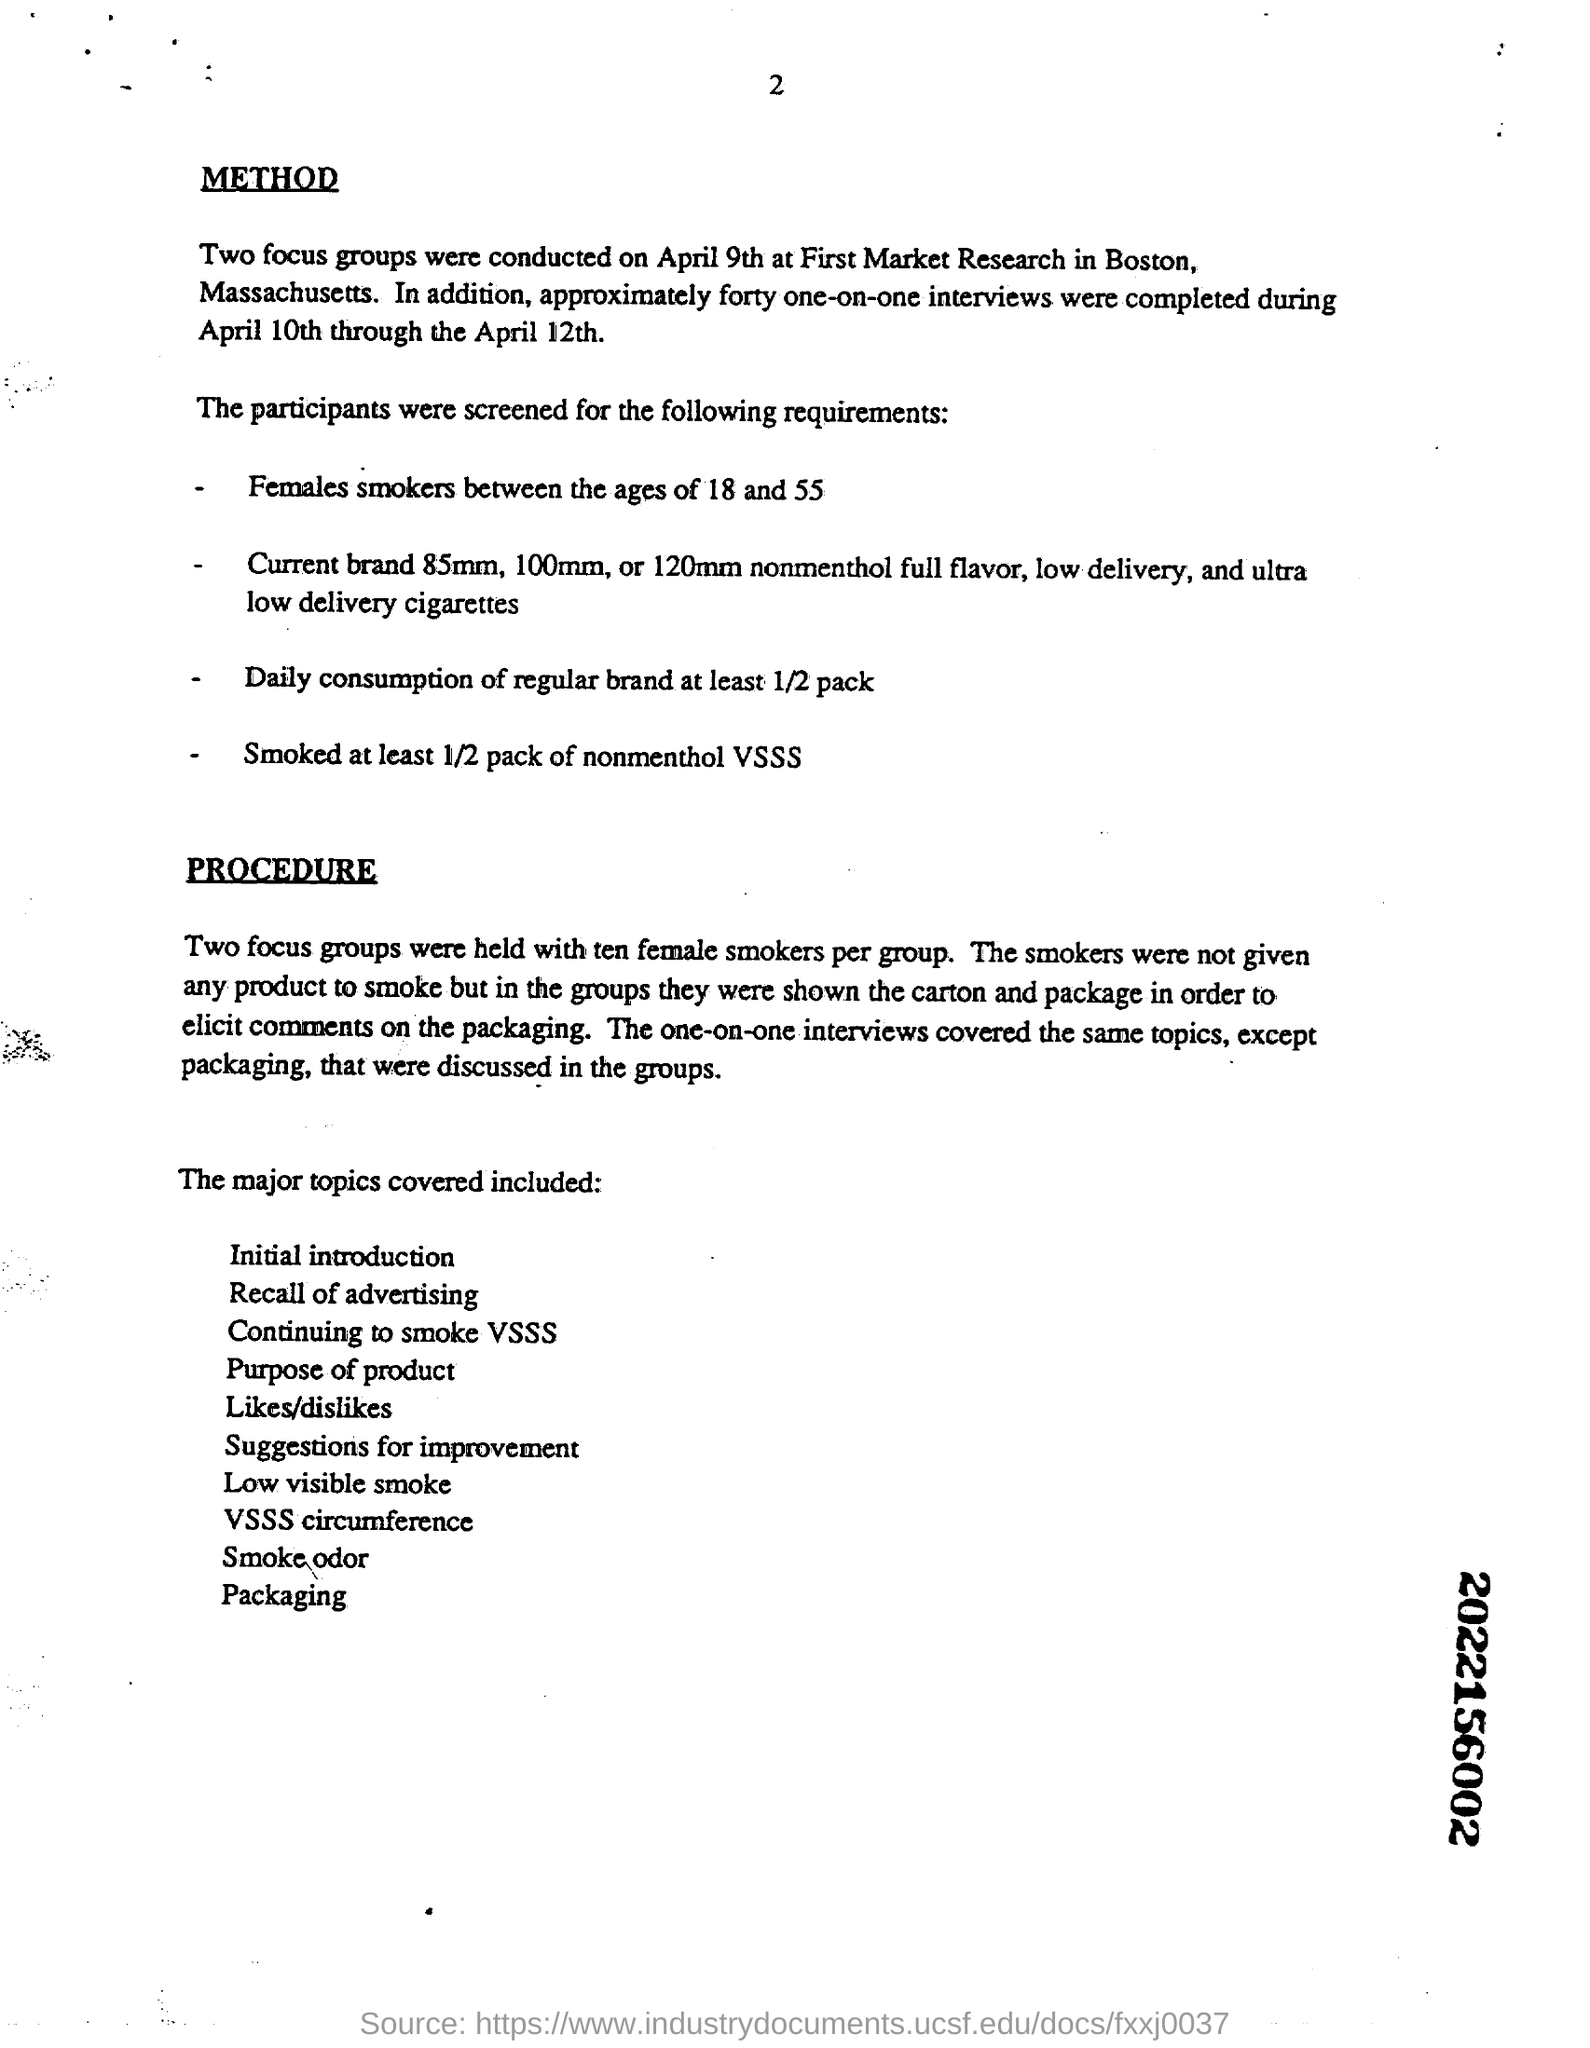How many one-on-one  interviews were completed during April 10th through the April 12th?
Make the answer very short. Forty. According to the listed requirements , what must be the age group of female smokers?
Your answer should be compact. Between the ages of 18 and 55. According to the requirements what is the minimum required consumption of a regular brand?
Make the answer very short. 1/2 pack. How many focus groups were held?
Give a very brief answer. Two. Which interviews covered the same topics, except packaging, that were discussed in groups?
Your answer should be very brief. The one-on-one interviews. 